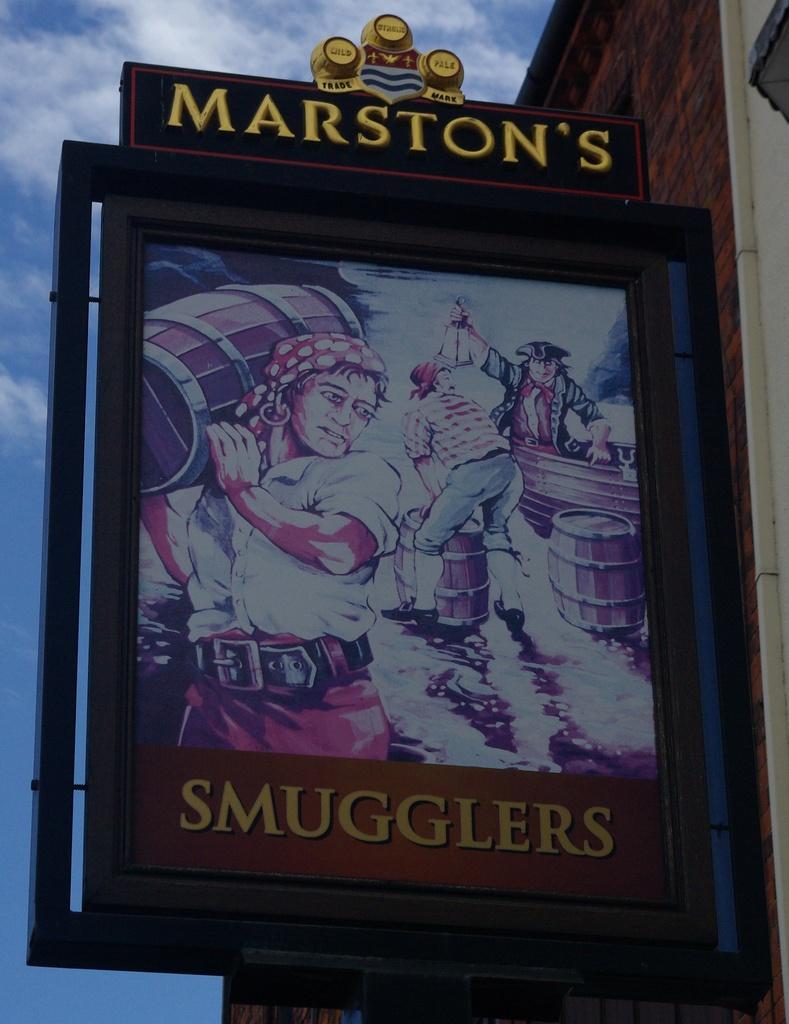How would you summarize this image in a sentence or two? In this picture in the center there is a board with some text and cartoon images on it which is on the wall of the building which is on the right side and the sky is cloudy. 